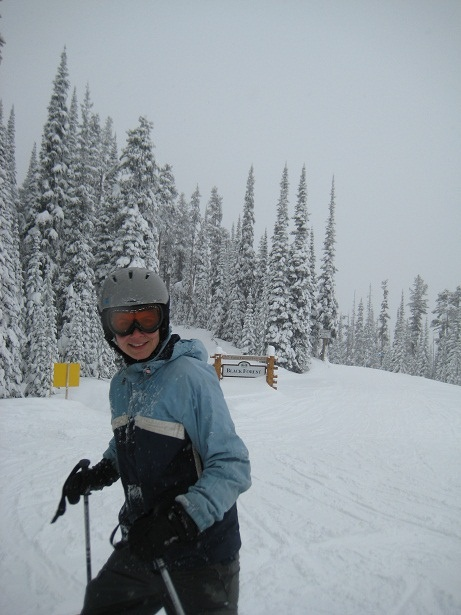Describe the objects in this image and their specific colors. I can see people in gray, black, and blue tones in this image. 